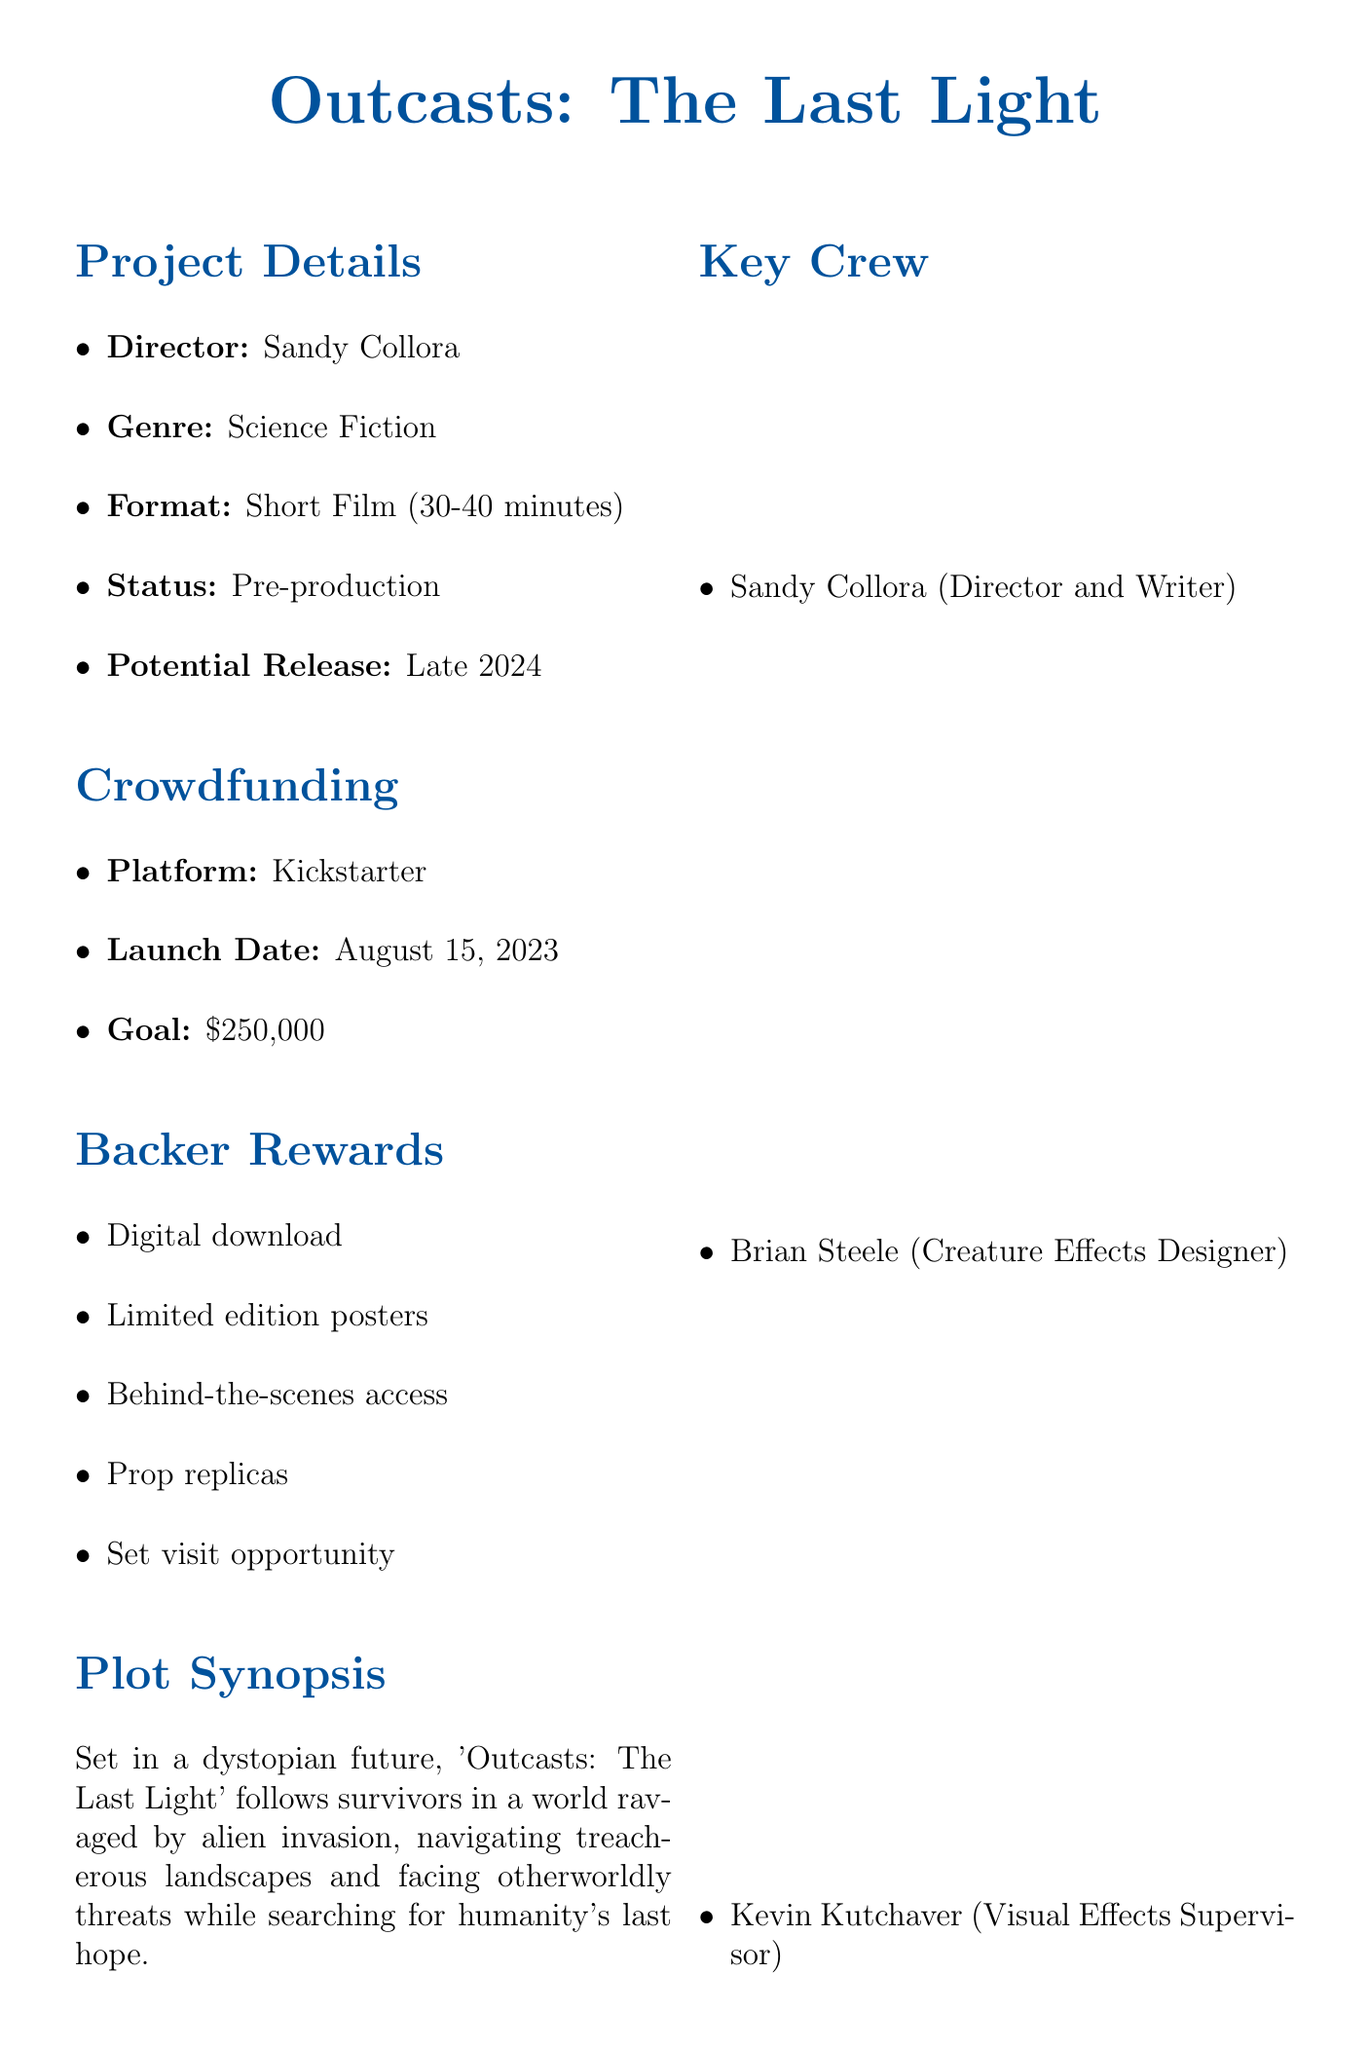What is the title of the film? The title of the film is presented prominently at the top of the document.
Answer: Outcasts: The Last Light Who is the director of the film? The document specifies the director's name, which is also a key team member.
Answer: Sandy Collora What is the estimated runtime of the film? The usual length of the film describes its potential runtime.
Answer: 30-40 minutes What is the crowdfunding goal? The goal for funding is clearly stated under the crowdfunding section.
Answer: $250,000 When does principal photography begin? The timeline of production details indicates when filming starts.
Answer: January 2024 Which crowdfunding platform is being used? The document lists the platform used for crowdfunding information.
Answer: Kickstarter What is the plot setting of the film? The synopsis provides details on the film's setting in a dystopian world.
Answer: Dystopian future Which festival is anticipated for screening in 2025? The document lists the festivals in which the film aims to participate.
Answer: Sundance Film Festival What type of effects will be predominantly used in the film? The document specifies the type of visual effects intended for the project.
Answer: Practical effects and CGI 